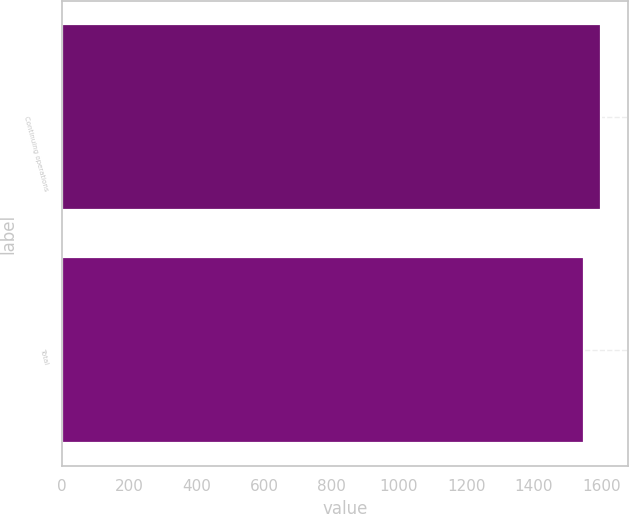Convert chart. <chart><loc_0><loc_0><loc_500><loc_500><bar_chart><fcel>Continuing operations<fcel>Total<nl><fcel>1601<fcel>1550<nl></chart> 